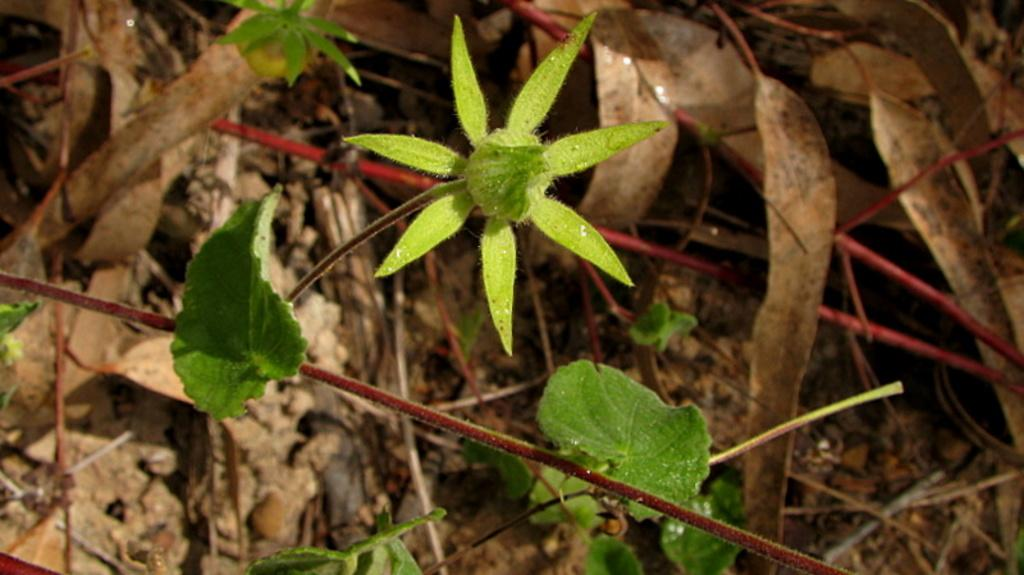What type of vegetation is present in the image? There are green leaves in the image. Can you describe the leaves in the right corner of the image? The leaves in the right corner of the image are dried. What type of carriage can be seen in the image? There is no carriage present in the image; it only features green and dried leaves. How many brothers are visible in the image? There are no people, including brothers, present in the image. 